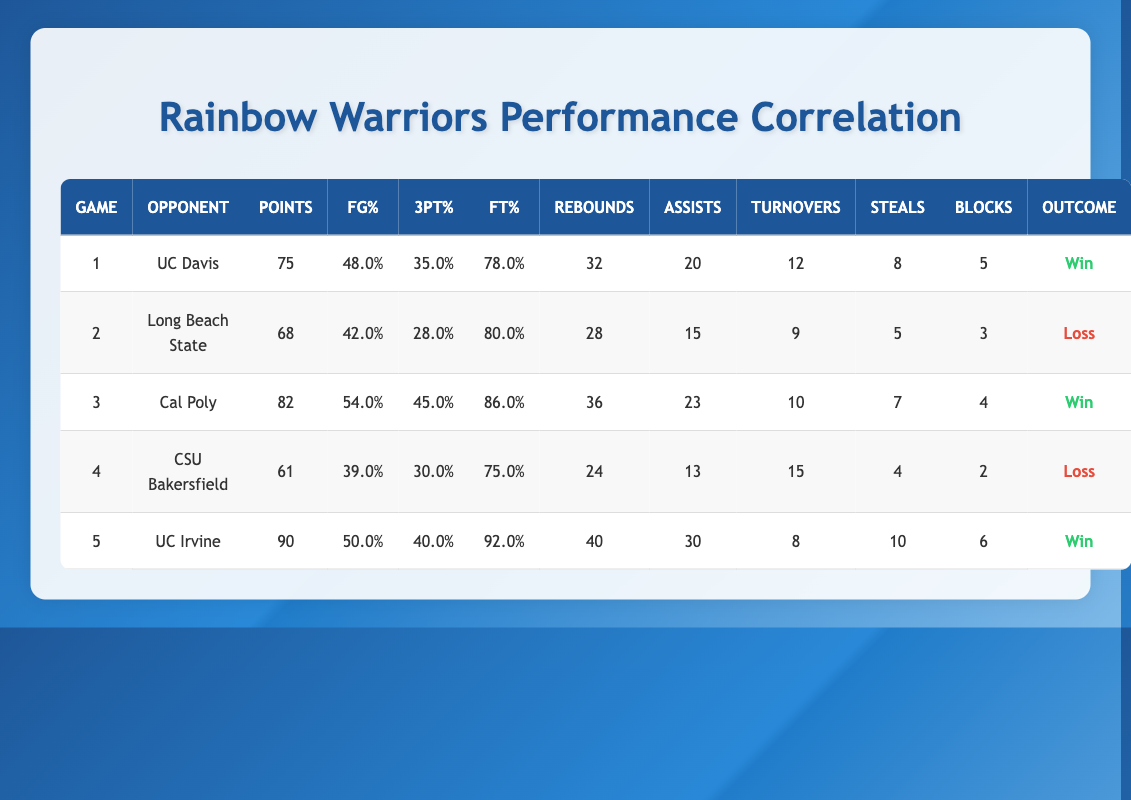What was the highest points scored in a game? Referring to the "Points" column, the highest value is 90 in game 5 versus UC Irvine.
Answer: 90 What was the field goal percentage in the win against UC Davis? In the row for game 1 (versus UC Davis), the field goal percentage is listed as 48.0%.
Answer: 48.0% How many games did the Rainbow Warriors win? There are three rows labeled "Win" in the "Outcome" column, which indicates that they won 3 games.
Answer: 3 What was the average number of rebounds in the games played? To find the average, add all rebounds: 32 + 28 + 36 + 24 + 40 = 160. Since there are 5 games, divide 160 by 5: 160 / 5 = 32.
Answer: 32 Did they have more turnovers than assists in the game against CSU Bakersfield? In the row for game 4 (CSU Bakersfield), there were 15 turnovers and 13 assists, which means they had more turnovers.
Answer: Yes What is the difference in points scored between the win against Cal Poly and the loss against Long Beach State? Cal Poly scored 82 points and Long Beach State scored 68 points. The difference is 82 - 68 = 14 points.
Answer: 14 Which game had the highest free throw percentage? The game against UC Irvine had the highest free throw percentage of 92.0%.
Answer: 92.0% Was the average three-point percentage for the games won higher than 35%? The three-point percentages for wins (35.0%, 45.0%, 40.0%) are summed: 35.0 + 45.0 + 40.0 = 120.0. The average is 120.0 / 3 = 40.0%, which is higher than 35%.
Answer: Yes How many steals did the Rainbow Warriors accumulate in their winning games? The steals in winning games are: 8 (UC Davis) + 7 (Cal Poly) + 10 (UC Irvine) = 25 total steals.
Answer: 25 